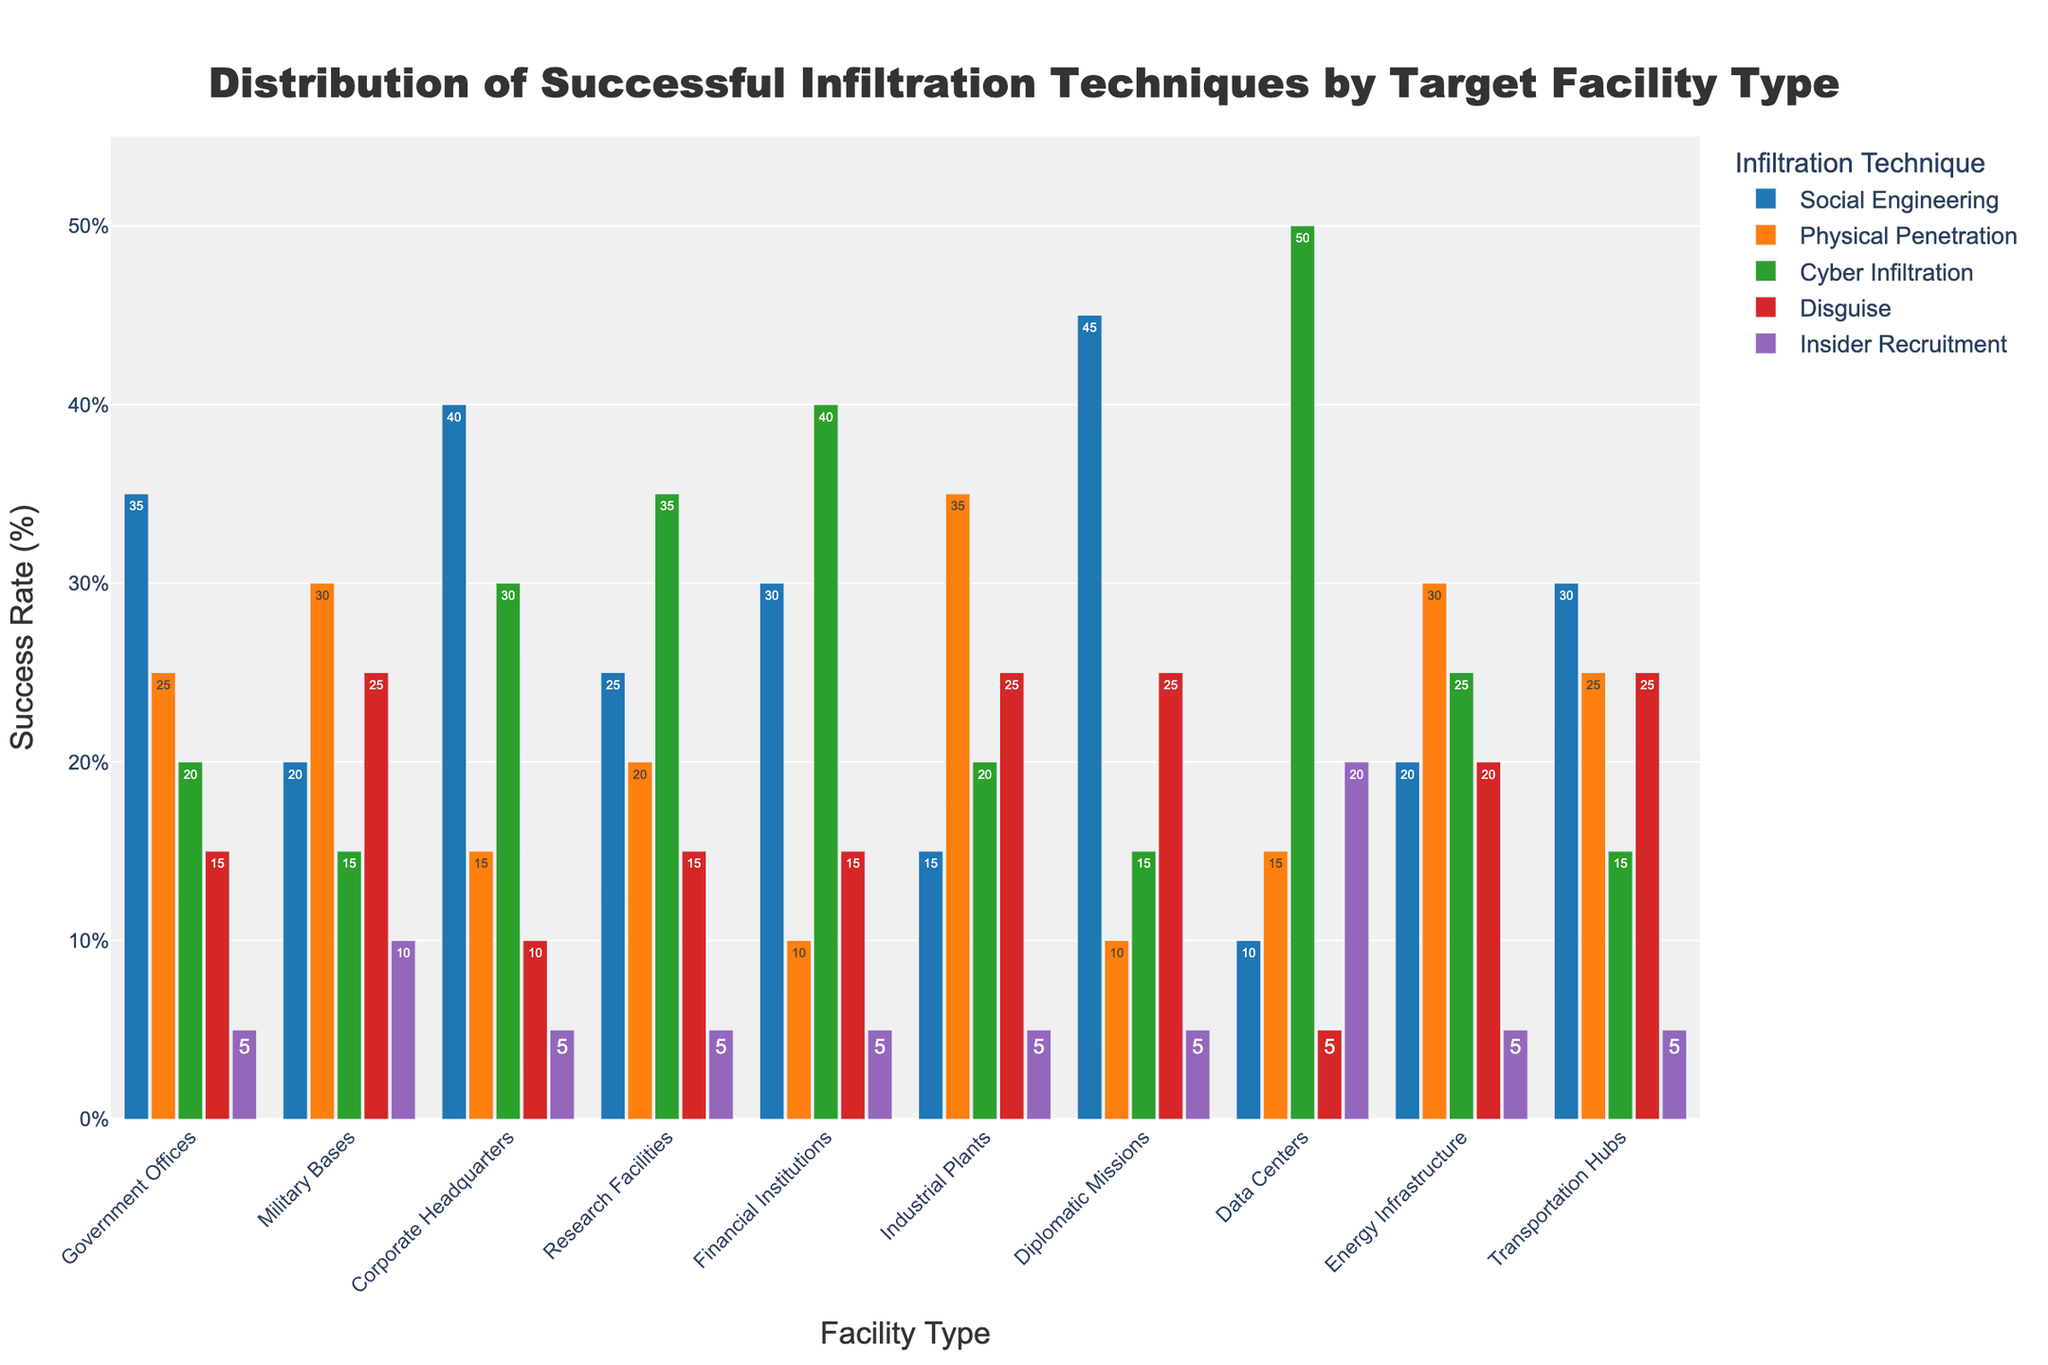Which facility type has the highest success rate for Social Engineering? Look at the bars representing Social Engineering across all facility types and identify the tallest one. The tallest bar for Social Engineering is over Diplomatic Missions, with a success rate of 45%.
Answer: Diplomatic Missions Which technique has the lowest average success rate across all facility types? Calculate the average success rate for each technique by summing their success rates across all facility types and dividing by the number of facilities. Cyber Infiltration has the lowest average success rate: (20+15+30+35+40+20+15+50+25+15)/10 = 26.5, considering the other techniques have higher averages.
Answer: Cyber Infiltration Which facilities have an equal success rate for Social Engineering and Insider Recruitment? Look at the bars for Social Engineering and Insider Recruitment across all facility types and compare their heights. Check where both bars are at the same level. Both Government Offices and Corporate Headquarters have equal success rates of 5% for Insider Recruitment and a higher but distinct rate for Social Engineering. Thus, none are equal.
Answer: None What is the success rate difference between the most and least effective technique for Data Centers? Identify the success rates for each technique at Data Centers and find the highest (Cyber Infiltration - 50%) and lowest (Disguise - 5%). Subtract the lowest from the highest. 50% - 5% = 45%.
Answer: 45% Which two techniques have the closest success rates across Military Bases? Examine the bars representing each technique for Military Bases and find the two that are closest in height. Physical Penetration (30%) and Cyber Infiltration (15%) are closer to each other.
Answer: Cyber Infiltration and Disguise What is the total success rate for all techniques in Government Offices? Sum the success rates for all techniques in the Government Offices category: 35 + 25 + 20 + 15 + 5 = 100%.
Answer: 100% Which facility type uses Disguise techniques most effectively? Look at the Disguise bars for all facility types and identify the tallest one. The tallest bar for Disguise is over Military Bases and Transportation Hubs with a success rate of 25%.
Answer: Military Bases and Transportation Hubs What is the range of success rates for Physical Penetration across all facility types? Find the highest (Industrial Plants - 35%) and lowest (Corporate Headquarters - 15%) success rates for Physical Penetration and subtract the lowest from the highest. 35% - 15% = 20%.
Answer: 20% How do success rates for Cyber Infiltration at Research Facilities compare to Energy Infrastructure? Look at the bars representing Cyber Infiltration at Research Facilities (35%) and Energy Infrastructure (25%). Research Facilities have a higher success rate than Energy Infrastructure by 10%.
Answer: Research Facilities have a higher success rate 